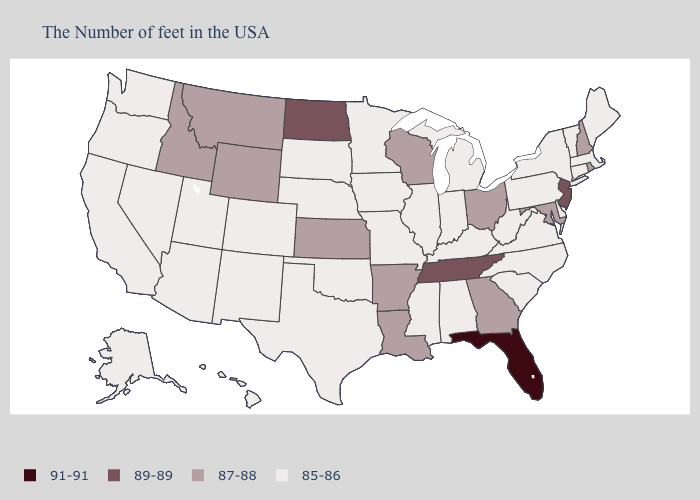What is the value of Tennessee?
Be succinct. 89-89. Name the states that have a value in the range 89-89?
Write a very short answer. New Jersey, Tennessee, North Dakota. Name the states that have a value in the range 91-91?
Give a very brief answer. Florida. What is the value of Minnesota?
Answer briefly. 85-86. Name the states that have a value in the range 89-89?
Concise answer only. New Jersey, Tennessee, North Dakota. What is the highest value in states that border Pennsylvania?
Concise answer only. 89-89. Among the states that border Minnesota , which have the lowest value?
Write a very short answer. Iowa, South Dakota. What is the highest value in the Northeast ?
Write a very short answer. 89-89. What is the value of North Carolina?
Concise answer only. 85-86. Which states have the lowest value in the USA?
Quick response, please. Maine, Massachusetts, Vermont, Connecticut, New York, Delaware, Pennsylvania, Virginia, North Carolina, South Carolina, West Virginia, Michigan, Kentucky, Indiana, Alabama, Illinois, Mississippi, Missouri, Minnesota, Iowa, Nebraska, Oklahoma, Texas, South Dakota, Colorado, New Mexico, Utah, Arizona, Nevada, California, Washington, Oregon, Alaska, Hawaii. What is the highest value in states that border Arizona?
Give a very brief answer. 85-86. What is the value of Texas?
Give a very brief answer. 85-86. What is the value of Nebraska?
Give a very brief answer. 85-86. How many symbols are there in the legend?
Concise answer only. 4. What is the value of New Mexico?
Quick response, please. 85-86. 